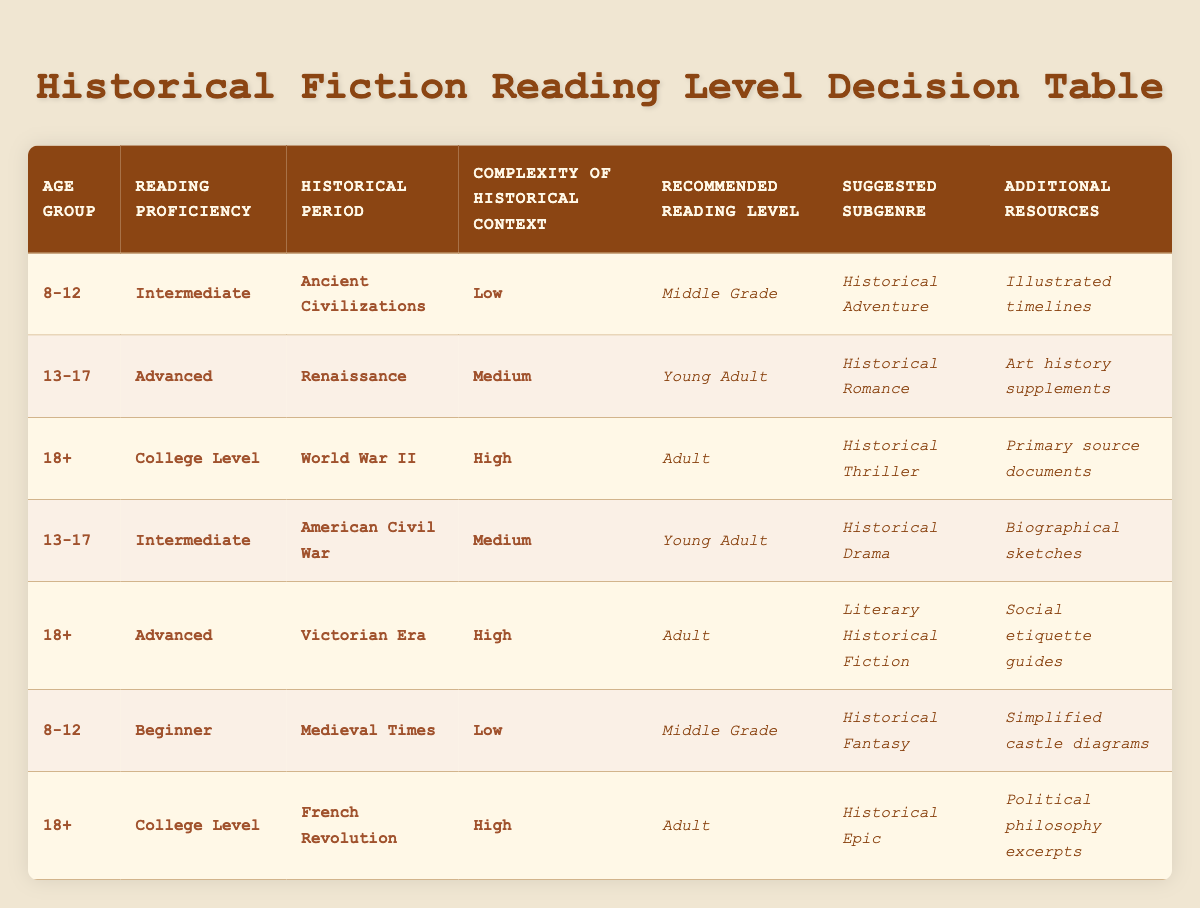What is the recommended reading level for 13-17 age group with advanced reading proficiency? In the table, we look for the row that matches the conditions: Age Group is 13-17 and Reading Proficiency is Advanced. In this case, we find that the recommended reading level is "Young Adult" for the historical period of Renaissance.
Answer: Young Adult Which subgenre is suggested for readers aged 8-12 with beginner reading proficiency interested in Medieval Times? By checking the specified parameters for Age Group and Reading Proficiency, we find the row corresponding to 8-12 and Beginner reading proficiency matches with Medieval Times, which suggests "Historical Fantasy".
Answer: Historical Fantasy True or False: A reader aged 18+ with advanced reading proficiency can choose Historical Adventure as a suggested subgenre. By examining the details, we note that the suggested subgenre for the 18+ age group with advanced reading proficiency is either "Literary Historical Fiction" or "Historical Epic", but not "Historical Adventure", which is suggested for 8-12 age group, making this statement false.
Answer: False What additional resources are offered for readers aged 18+ studying the French Revolution? We find that for the 18+ age group studying the French Revolution, the additional resources provided are "Political philosophy excerpts", which is mentioned in that specific row in the table.
Answer: Political philosophy excerpts If we combine the historical periods listed for the age group 13-17, how many unique historical periods are represented? For the age group 13-17, we see two unique historical periods: "Renaissance" and "American Civil War". Thus, adding them gives us a total of 2 unique periods represented for that age group.
Answer: 2 Which reading level corresponds to the complexity of historical context labeled as "High"? Reviewing the table, we find that the reading level for "High" complexity of historical context is consistently listed as "Adult" for both World War II and Victorian Era, indicating that those who read these genres are expected to have a higher reading level.
Answer: Adult Is there any suggested subgenre for the 8-12 age group that does not have additional resources mentioned? Looking through the entries for the 8-12 age group, we observe that both "Historical Adventure" and "Historical Fantasy" have specific additional resources listed. Therefore, the answer is that there is no subgenre without additional resources.
Answer: No 